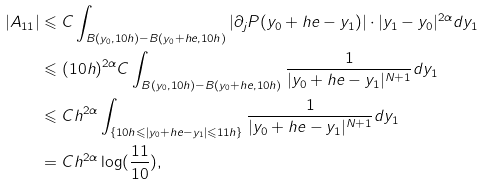<formula> <loc_0><loc_0><loc_500><loc_500>| A _ { 1 1 } | & \leqslant C \int _ { B ( y _ { 0 } , 1 0 h ) - B ( y _ { 0 } + h e , 1 0 h ) } | \partial _ { j } P ( y _ { 0 } + h e - y _ { 1 } ) | \cdot | y _ { 1 } - y _ { 0 } | ^ { 2 \alpha } d y _ { 1 } \\ & \leqslant ( 1 0 h ) ^ { 2 \alpha } C \int _ { B ( y _ { 0 } , 1 0 h ) - B ( y _ { 0 } + h e , 1 0 h ) } \frac { 1 } { | y _ { 0 } + h e - y _ { 1 } | ^ { N + 1 } } d y _ { 1 } \\ & \leqslant C h ^ { 2 \alpha } \int _ { \{ 1 0 h \leqslant | y _ { 0 } + h e - y _ { 1 } | \leqslant 1 1 h \} } \frac { 1 } { | y _ { 0 } + h e - y _ { 1 } | ^ { N + 1 } } d y _ { 1 } \\ & = C h ^ { 2 \alpha } \log ( \frac { 1 1 } { 1 0 } ) ,</formula> 